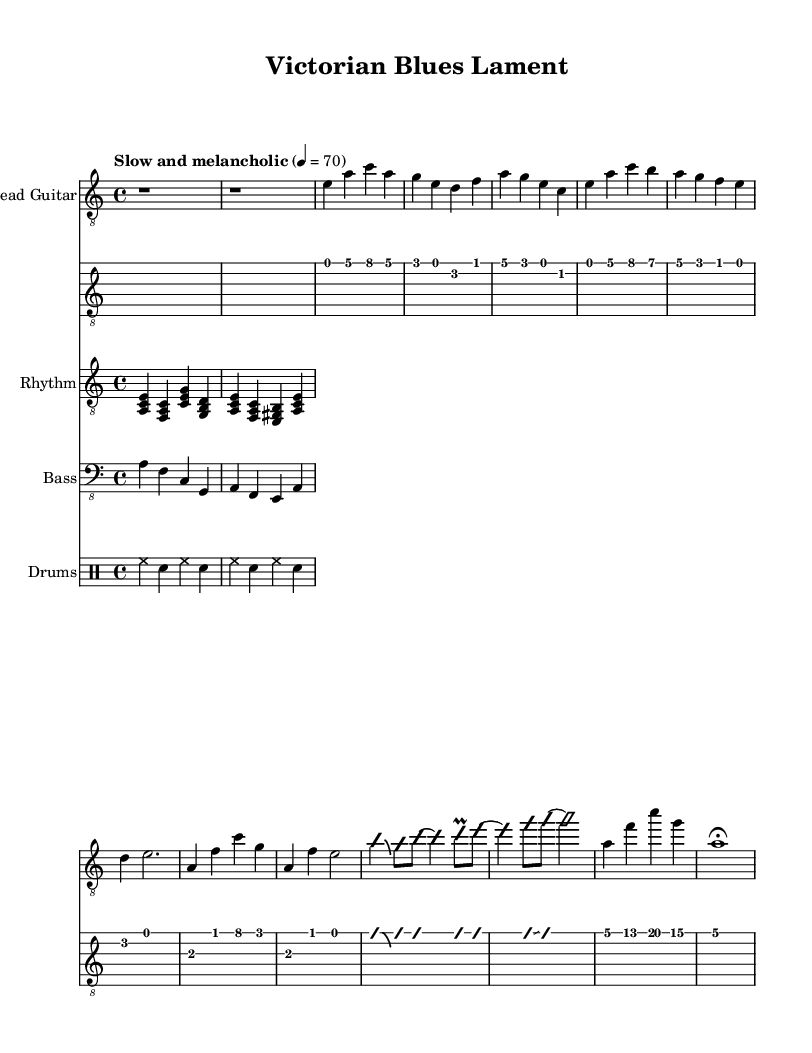What is the key signature of this music? The key signature is indicated as "a minor" within the global context, which means there are no sharps or flats in this key.
Answer: a minor What is the time signature of this sheet music? The time signature is shown as "4/4" in the global context, which signifies that there are four beats per measure and the quarter note receives one beat.
Answer: 4/4 What is the tempo marking for this piece? The tempo marking is indicated as "Slow and melancholic," with a metronome marking of quarter note equals 70 beats per minute.
Answer: Slow and melancholic How many measures are in the guitar solo? The guitar solo consists of two measures, as indicated by the notation for the improvisation on the lead guitar section.
Answer: 2 measures What is the instrument that plays the lead part? The lead part is played on the "Lead Guitar," which is indicated at the beginning of the staff for the electric guitar.
Answer: Lead Guitar Which chords are used in the rhythm guitar part? The rhythm guitar part utilizes the chords A minor, F major, C major, and G major based on the provided chord shapes that correspond to the notes played.
Answer: A minor, F major, C major, G major What type of music is this score classified as? This music score is specifically classified as "Electric Blues," which is apparent in the title "Victorian Blues Lament" and the blues-influenced structure of the melodies and chords.
Answer: Electric Blues 